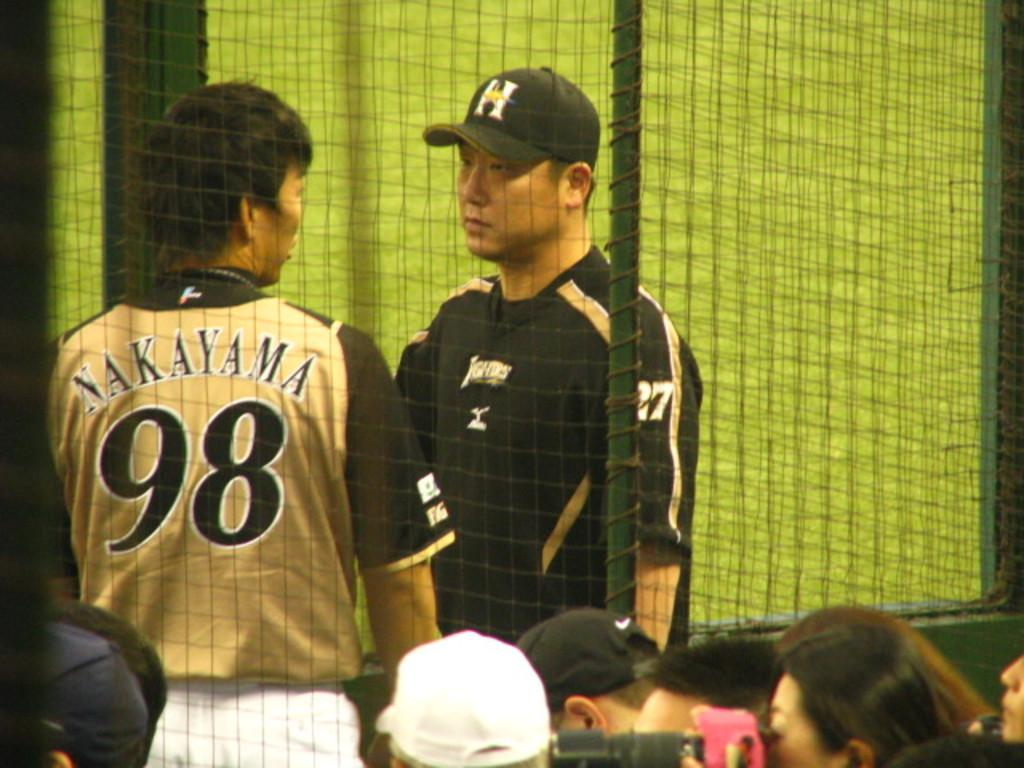<image>
Give a short and clear explanation of the subsequent image. Baseball player wearing number  98 talking to another man. 